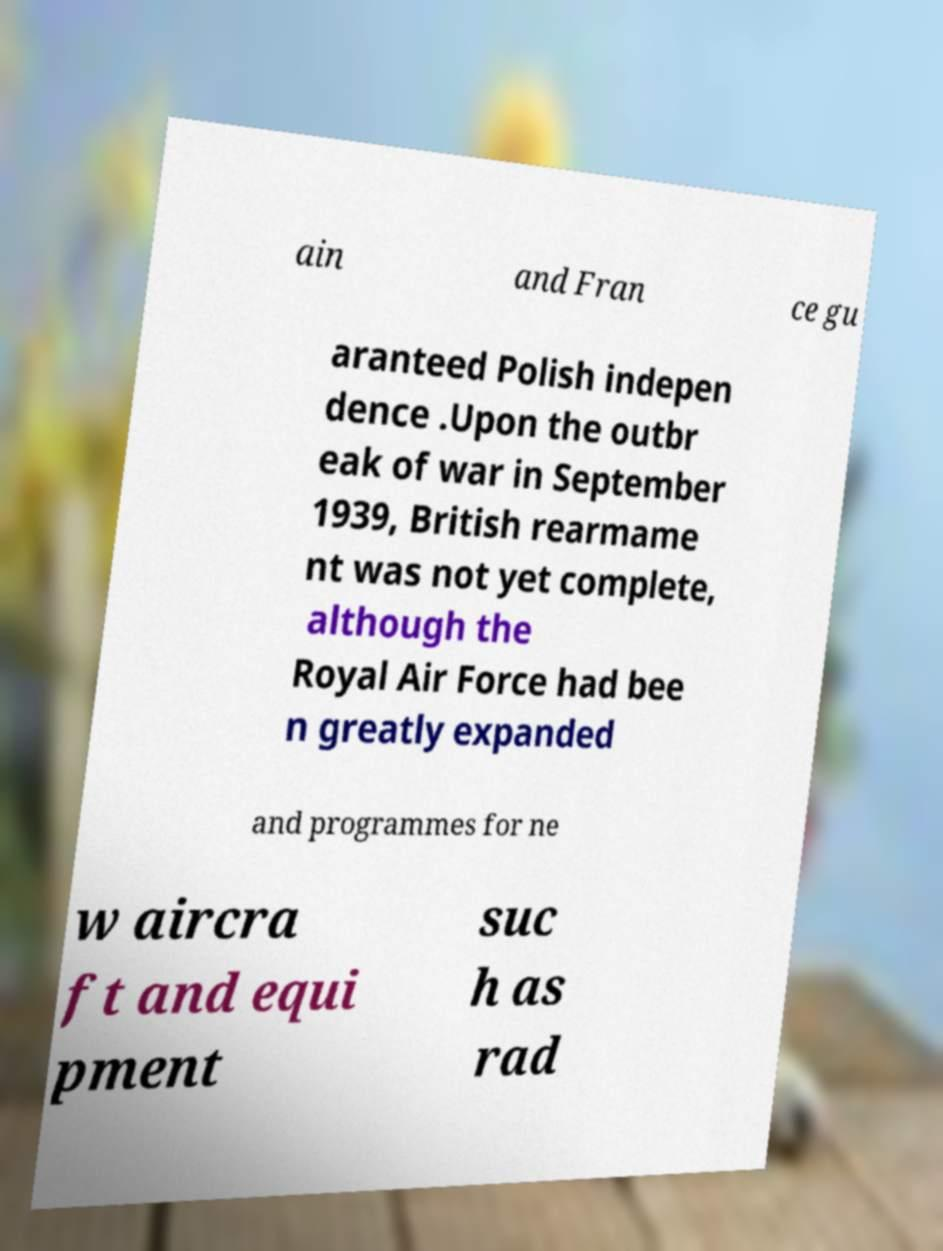Please identify and transcribe the text found in this image. ain and Fran ce gu aranteed Polish indepen dence .Upon the outbr eak of war in September 1939, British rearmame nt was not yet complete, although the Royal Air Force had bee n greatly expanded and programmes for ne w aircra ft and equi pment suc h as rad 